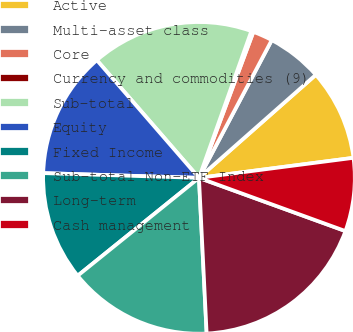Convert chart. <chart><loc_0><loc_0><loc_500><loc_500><pie_chart><fcel>Active<fcel>Multi-asset class<fcel>Core<fcel>Currency and commodities (9)<fcel>Sub-total<fcel>Equity<fcel>Fixed Income<fcel>Sub-total Non-ETF Index<fcel>Long-term<fcel>Cash management<nl><fcel>9.45%<fcel>5.76%<fcel>2.06%<fcel>0.22%<fcel>16.83%<fcel>13.14%<fcel>11.29%<fcel>14.98%<fcel>18.67%<fcel>7.6%<nl></chart> 